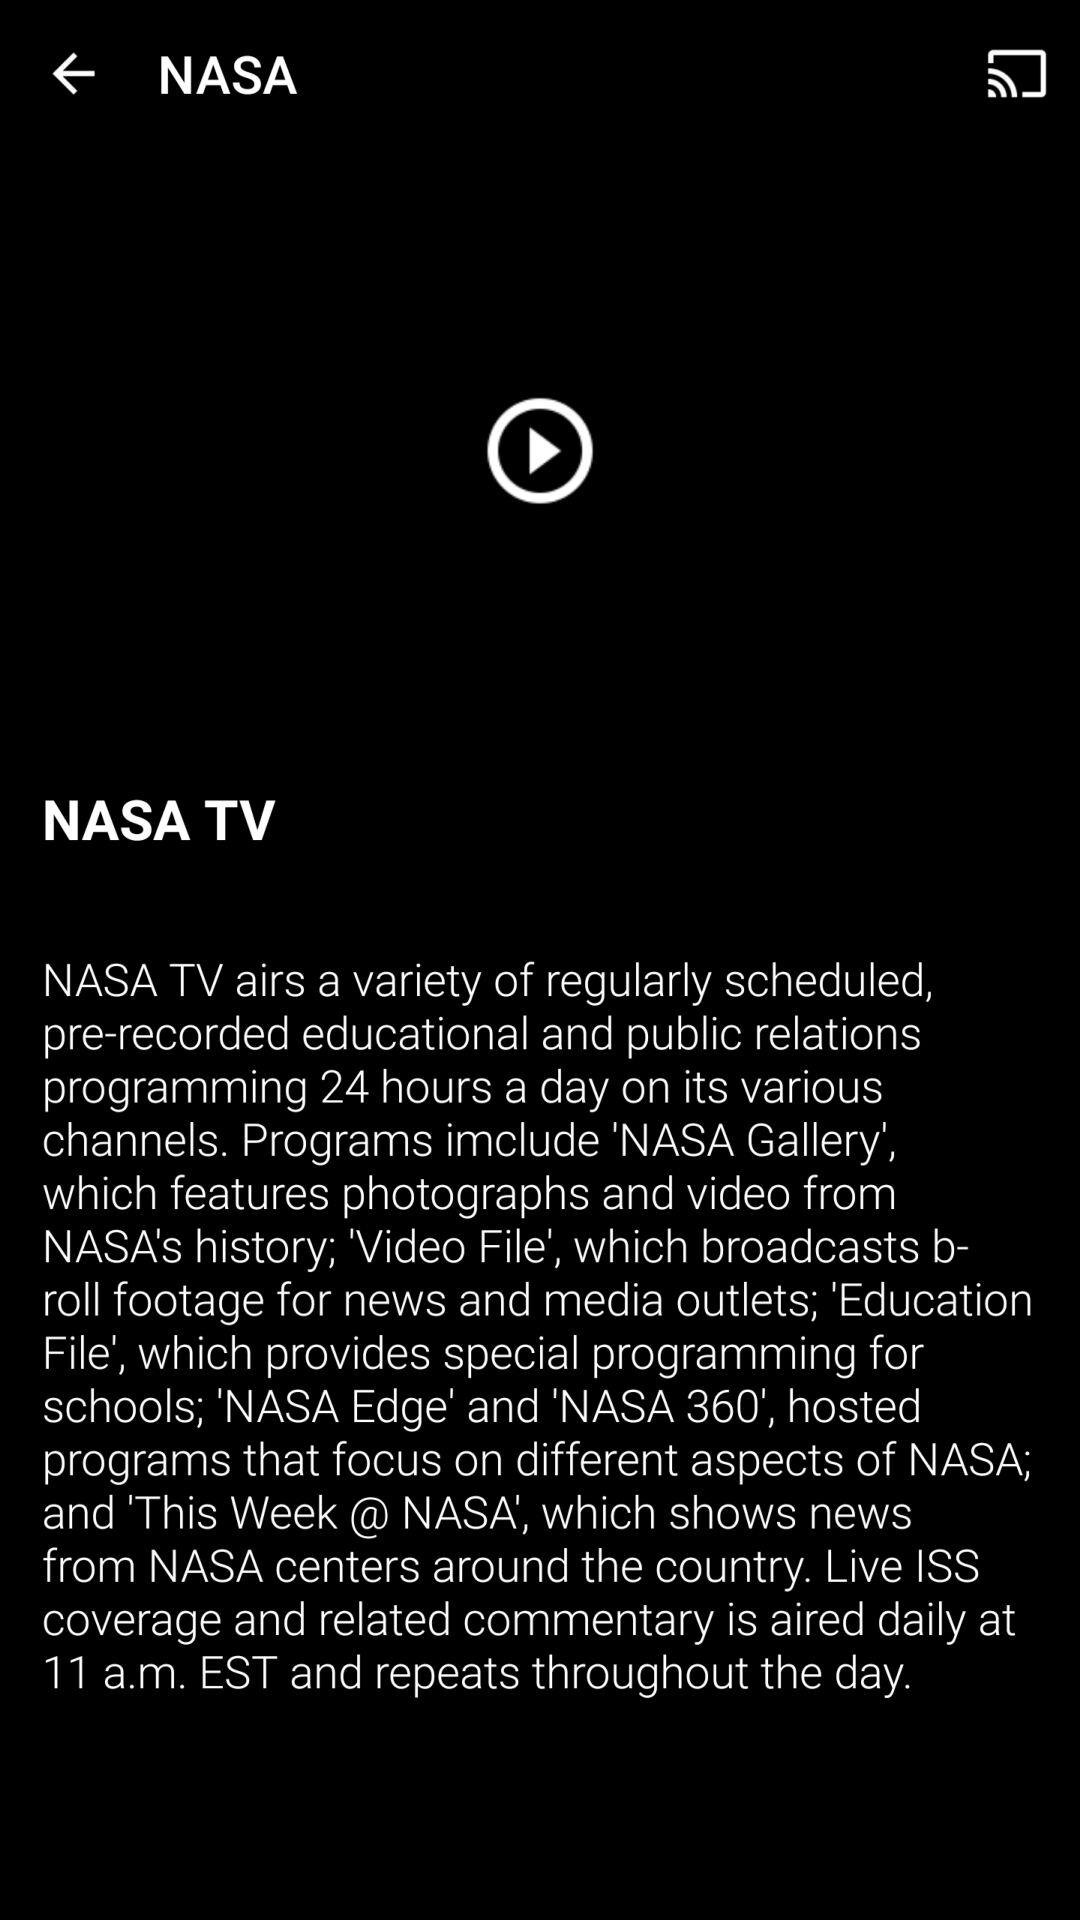How many hours per day does NASA TV air educational and public relations programming?
Answer the question using a single word or phrase. 24 